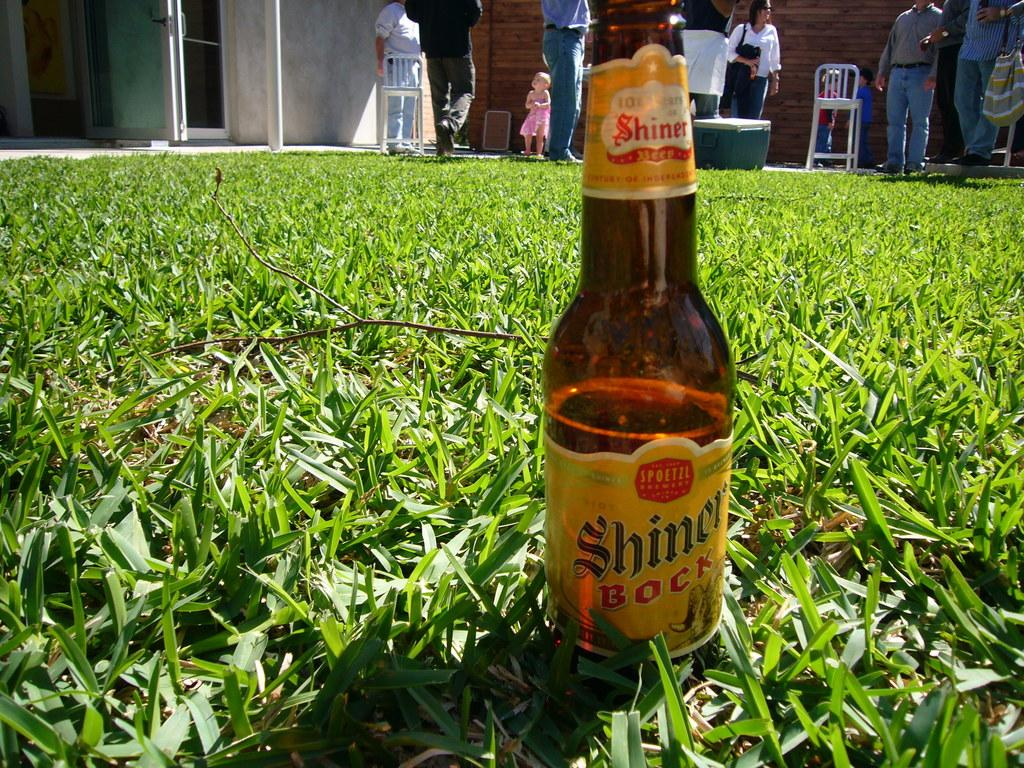What is on the grass in the image? There is a beer bottle on the grass in the image. What brand of beer is in the bottle? The beer bottle has the label "Shiner Bock" on it. What can be seen in the background of the image? There are people, chairs, and a house in the background of the image. How many stitches are visible on the cat's paw in the image? There is no cat present in the image, so it is not possible to determine the number of stitches on its paw. 